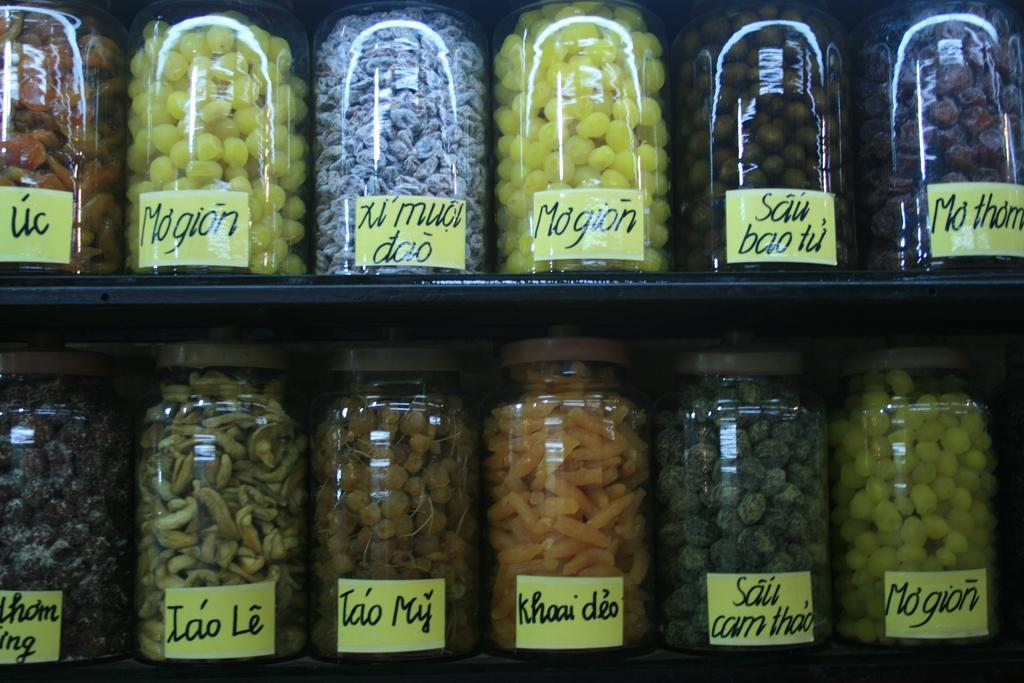What objects are present in the image? There are containers in the image. What are the containers holding? The containers are filled with food items. How are the containers decorated or labeled? There are stickers on the containers. How are the containers arranged or stored? The containers are placed on racks. What is the market's desire for milk in the image? A: There is no market or mention of milk in the image; it only features containers filled with food items and placed on racks. 